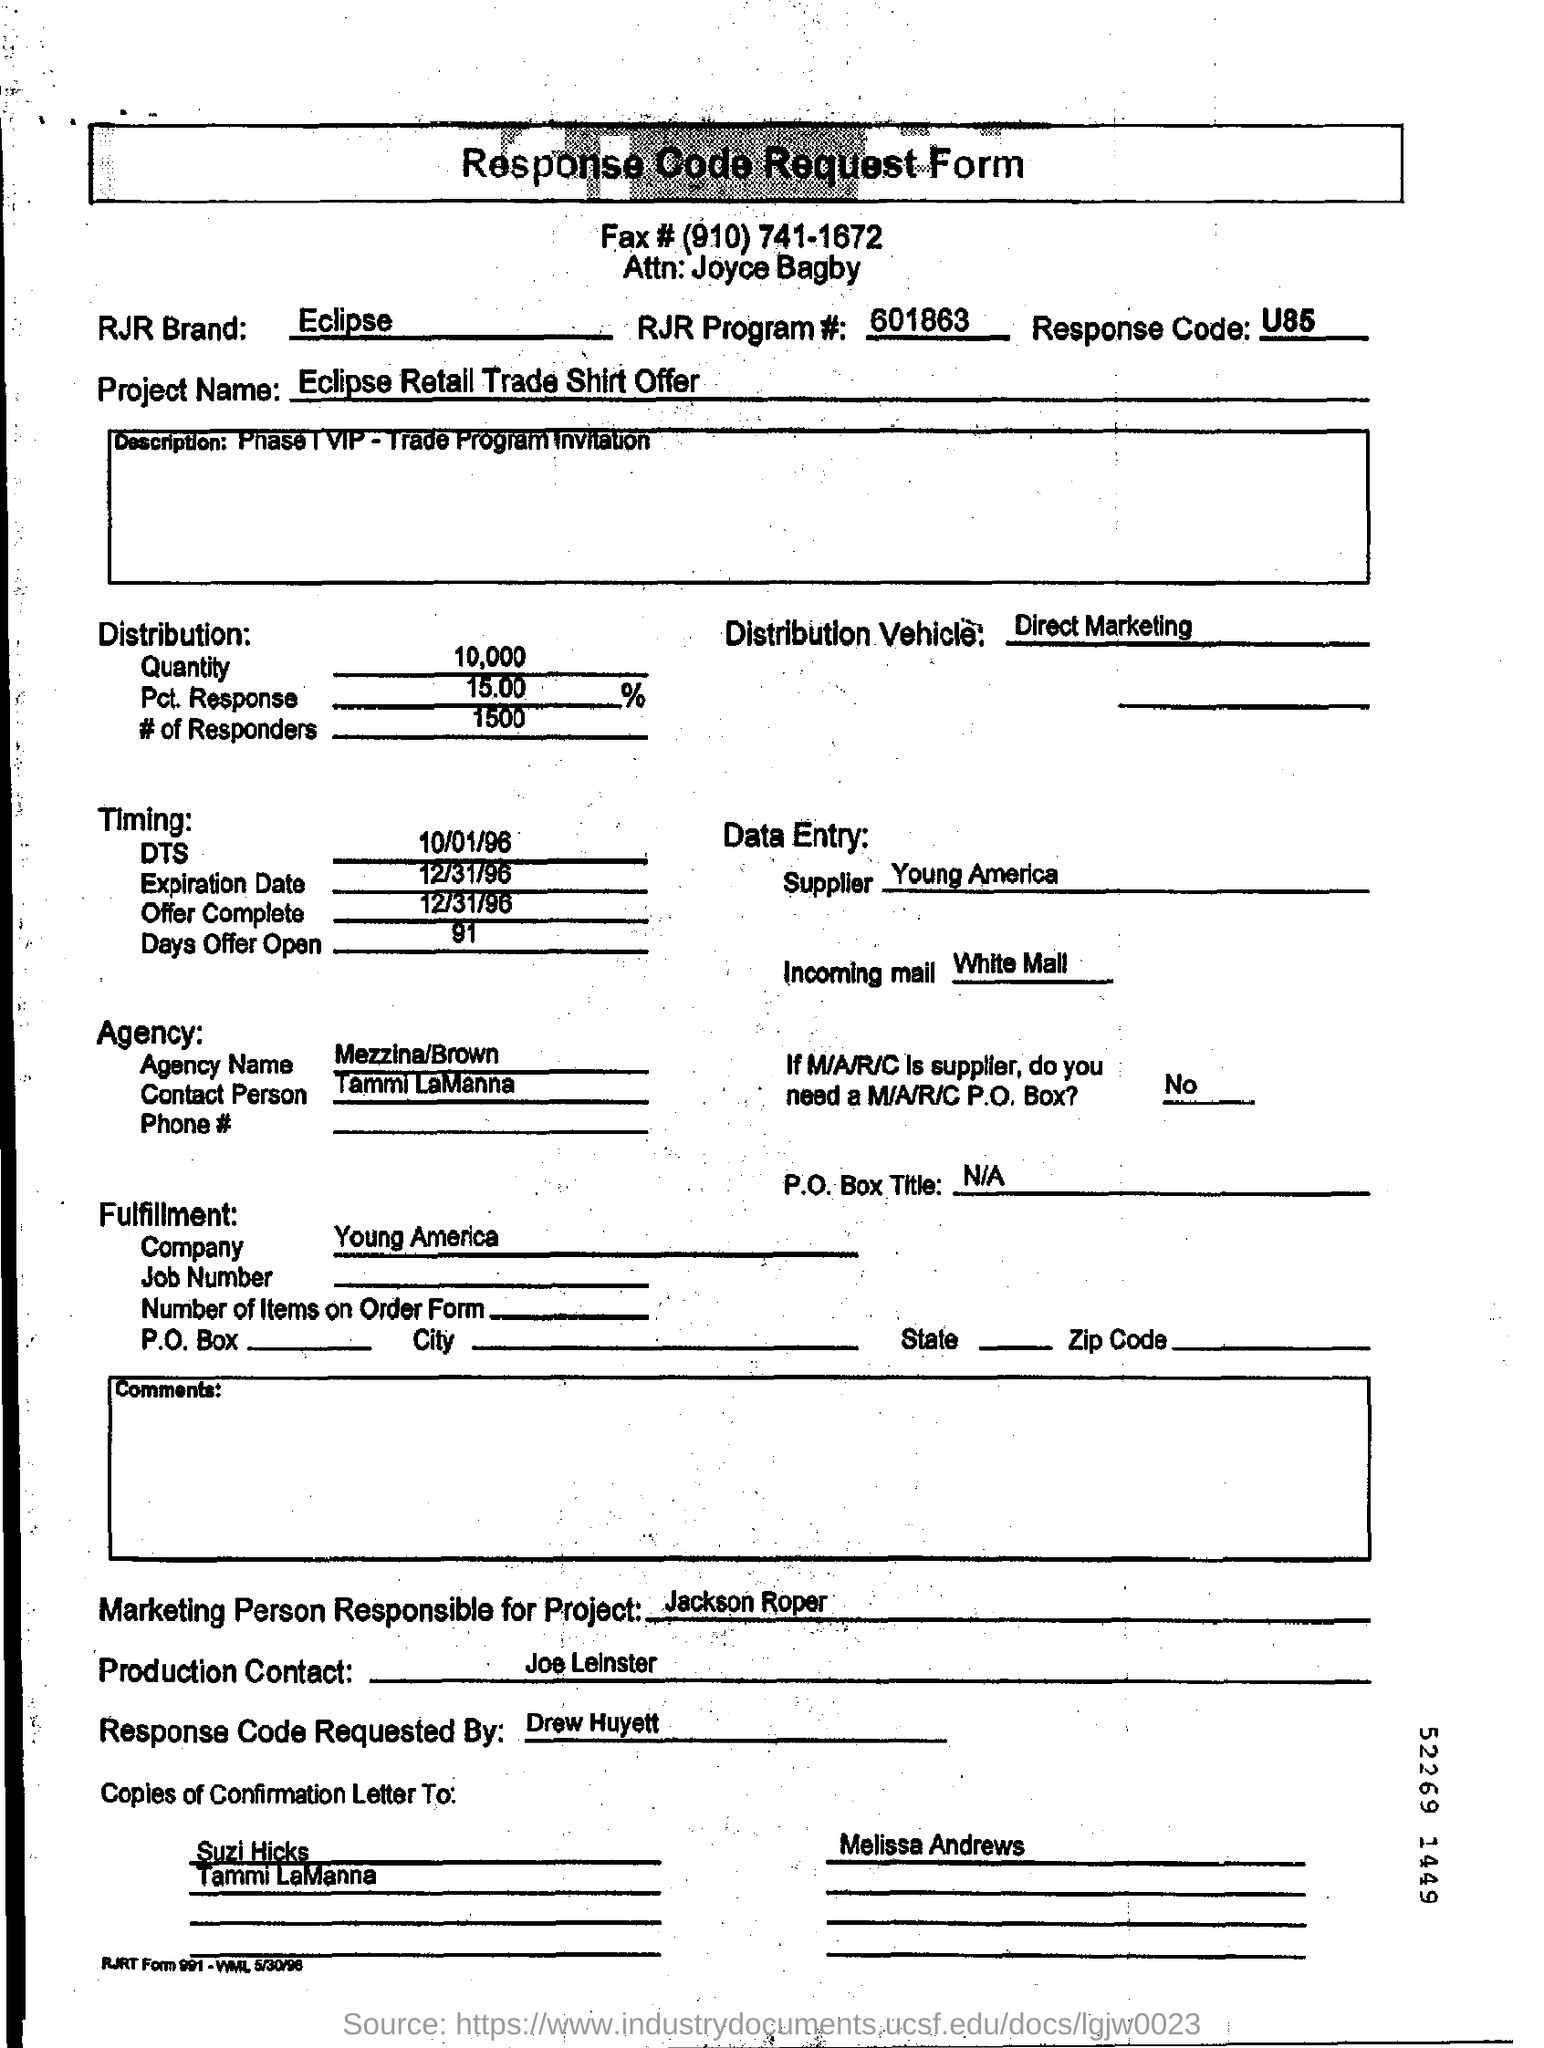Identify some key points in this picture. The response code is U85.. The person responsible for the marketing aspect of the project is named Jackson Roper. The response code request form lists 1500 responders. I, Drew Huyett, am requesting a confirmation of the response code. The offer is currently open for a period of 91... 